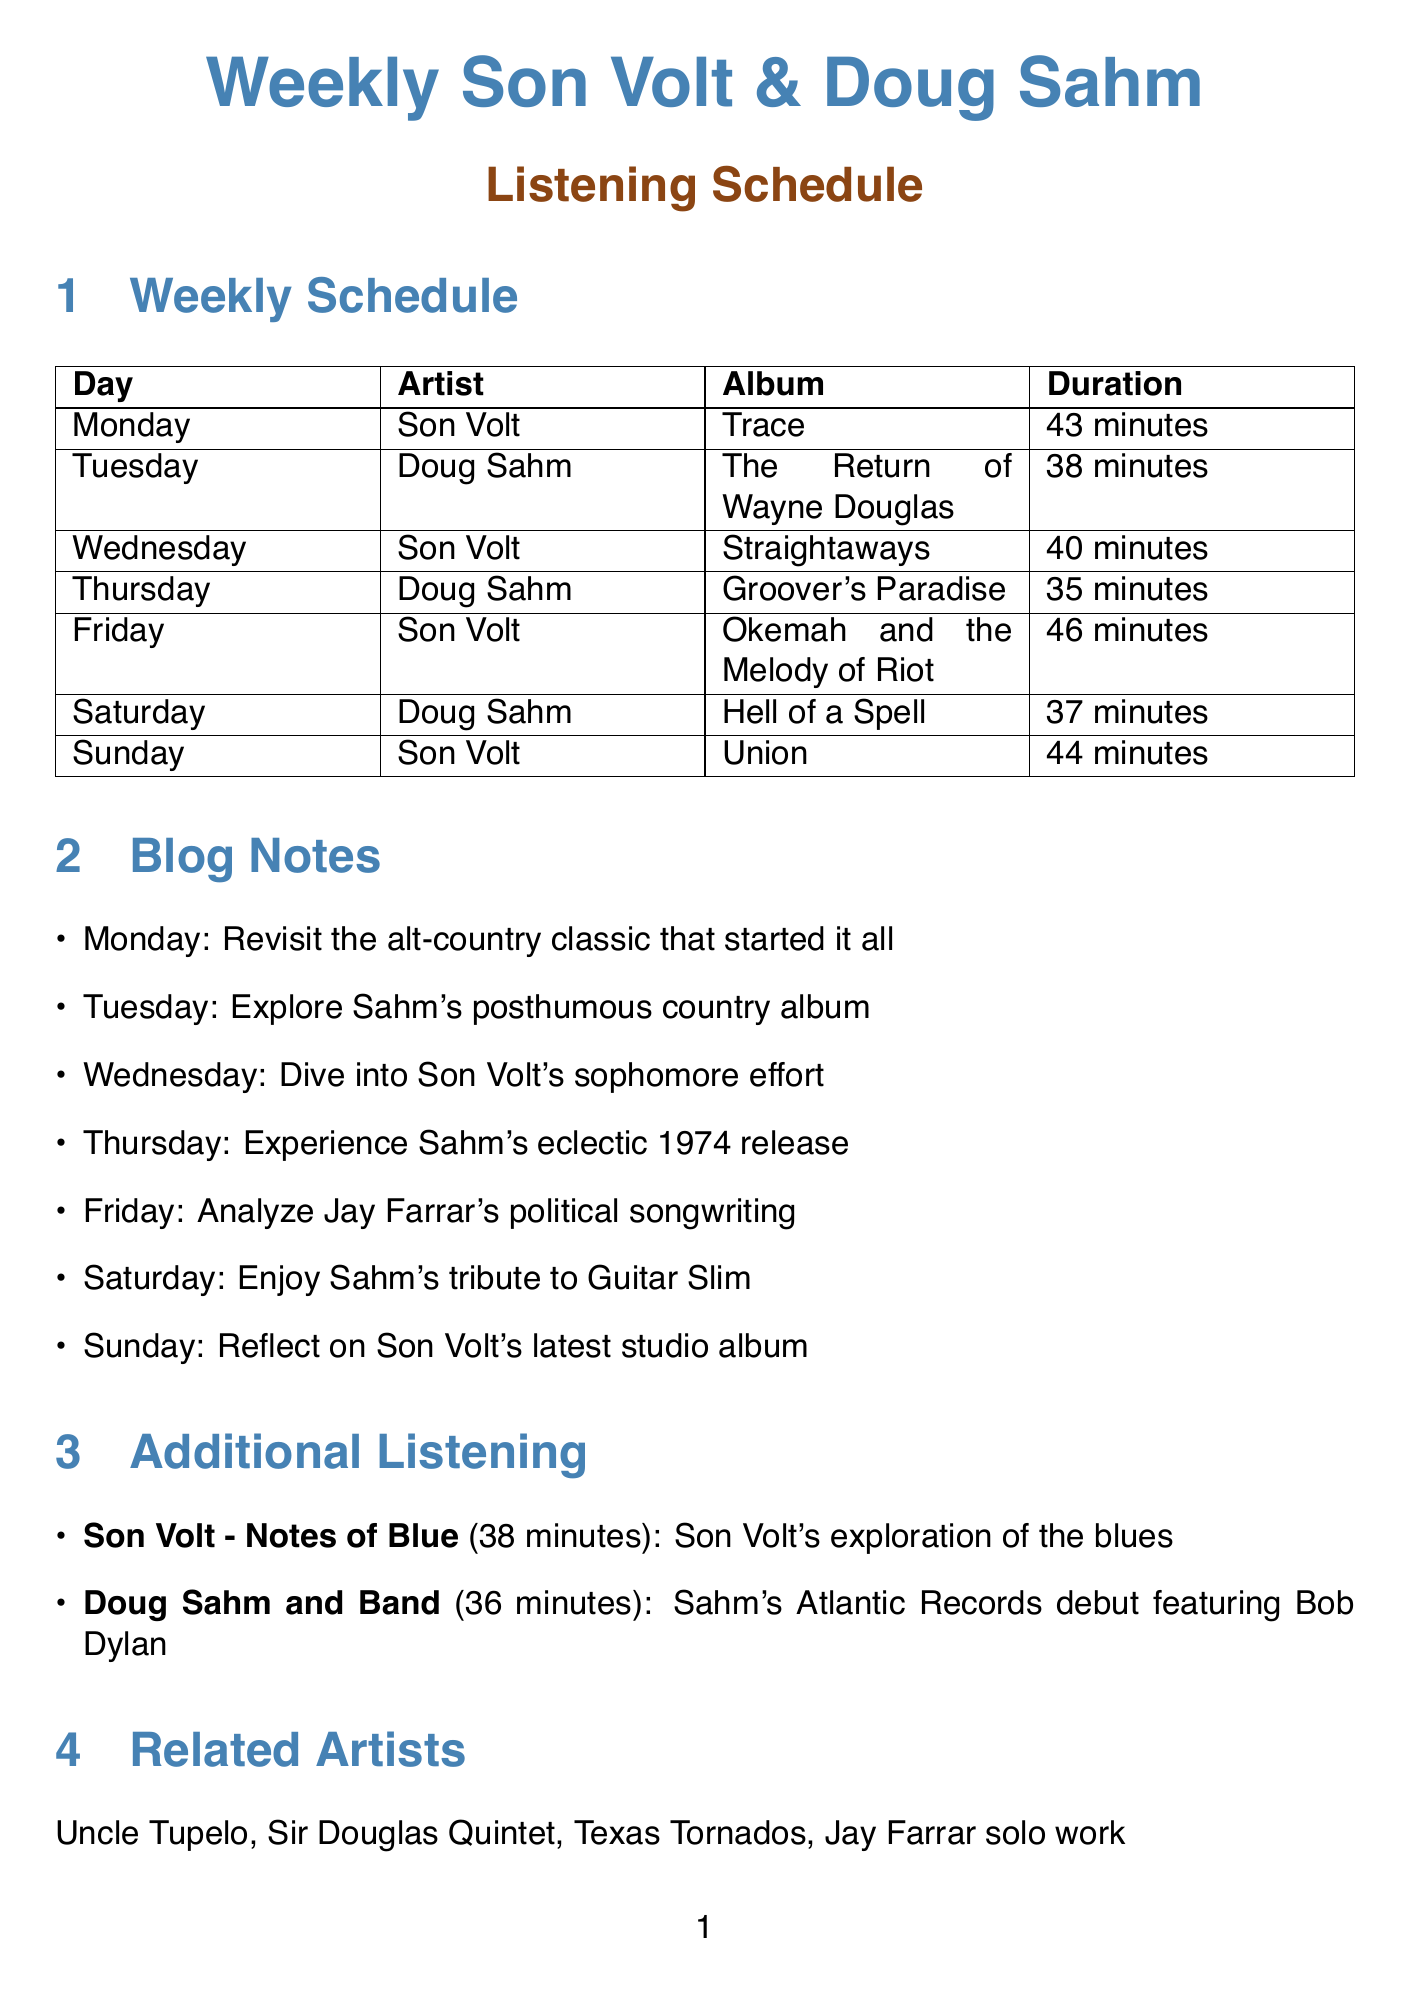what album does Son Volt listen to on Monday? The document specifies that on Monday, the album being listened to by Son Volt is "Trace."
Answer: Trace what is the duration of Doug Sahm's album "Groover's Paradise"? The document states that the duration of "Groover's Paradise" is 35 minutes.
Answer: 35 minutes which artist is featured on Saturday's schedule? The document lists Doug Sahm as the artist for Saturday's listening schedule.
Answer: Doug Sahm how many minutes long is the album "Okemah and the Melody of Riot"? According to the document, "Okemah and the Melody of Riot" has a duration of 46 minutes.
Answer: 46 minutes what is the blog note for Wednesday's listening? The document mentions that on Wednesday, the blog note is to "Dive into Son Volt's sophomore effort."
Answer: Dive into Son Volt's sophomore effort which album is mentioned as Son Volt's exploration of the blues? The document indicates that "Notes of Blue" is Son Volt's exploration of the blues.
Answer: Notes of Blue what day is dedicated to reflecting on Son Volt's latest studio album? The schedule specifies that Sunday is the day for reflecting on Son Volt's latest studio album.
Answer: Sunday list one related artist mentioned in the document The document provides a list of related artists including Uncle Tupelo.
Answer: Uncle Tupelo how many blog ideas are listed in the document? The document states that there are 5 blog ideas listed.
Answer: 5 